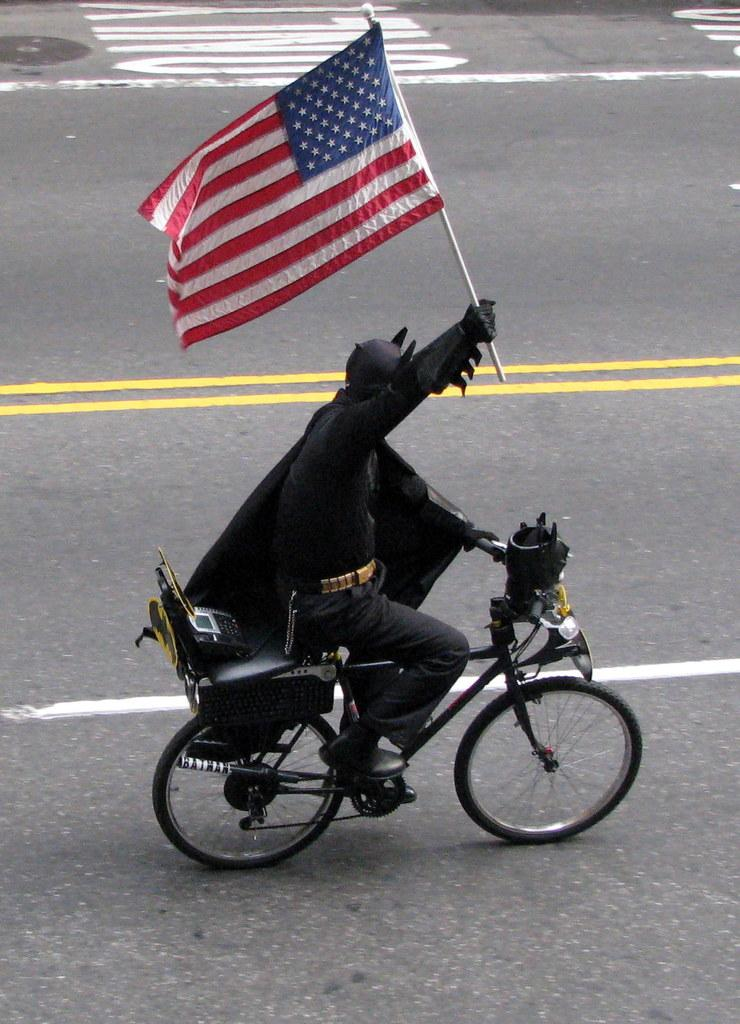What is the main subject of the image? There is a person in the image. What is the person doing in the image? The person is riding a cycle. What is the person wearing in the image? The person is wearing a Batman costume. What object is the person holding in the image? The person is holding a flag in their hand. Is the person's partner sitting on the table in the image? There is no table or partner present in the image. 